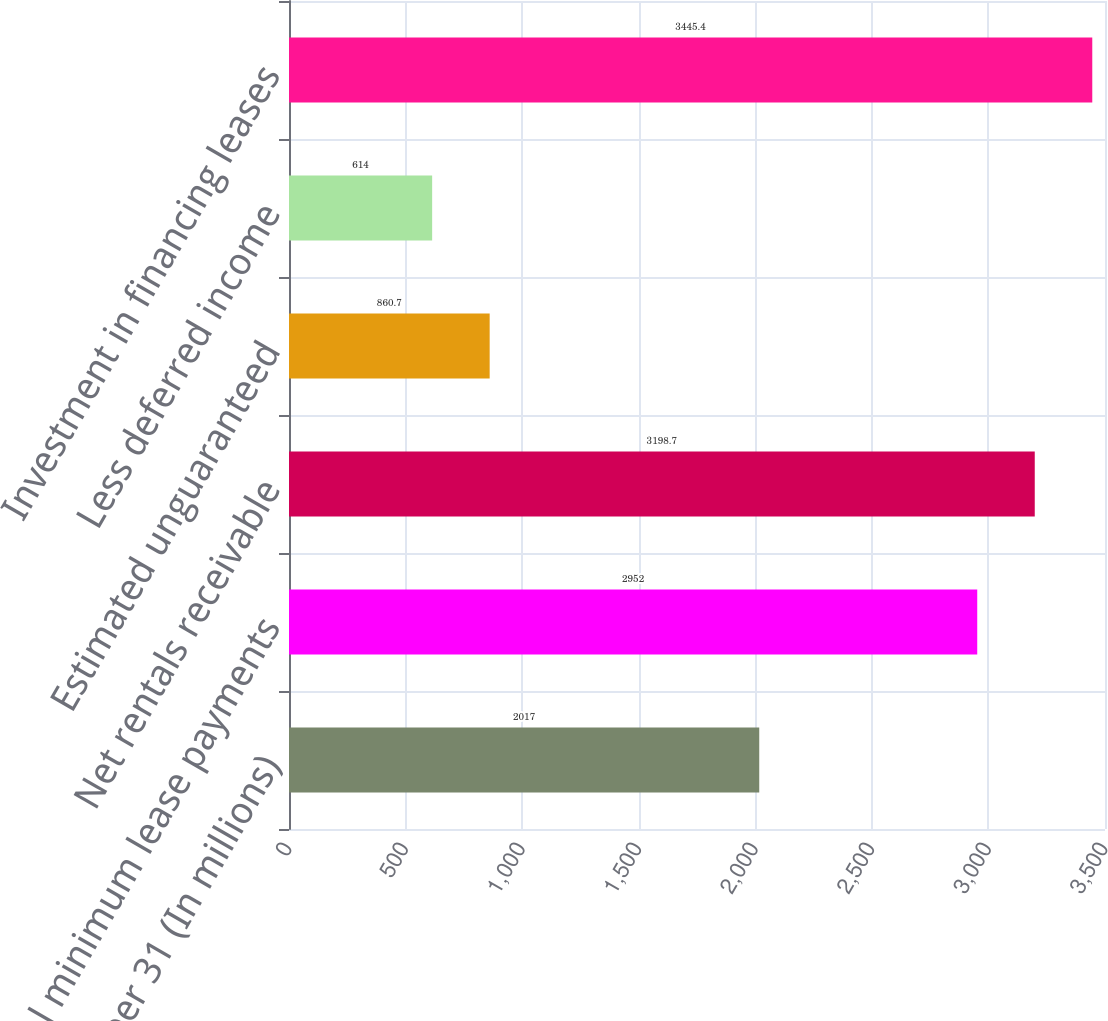Convert chart. <chart><loc_0><loc_0><loc_500><loc_500><bar_chart><fcel>December 31 (In millions)<fcel>Total minimum lease payments<fcel>Net rentals receivable<fcel>Estimated unguaranteed<fcel>Less deferred income<fcel>Investment in financing leases<nl><fcel>2017<fcel>2952<fcel>3198.7<fcel>860.7<fcel>614<fcel>3445.4<nl></chart> 